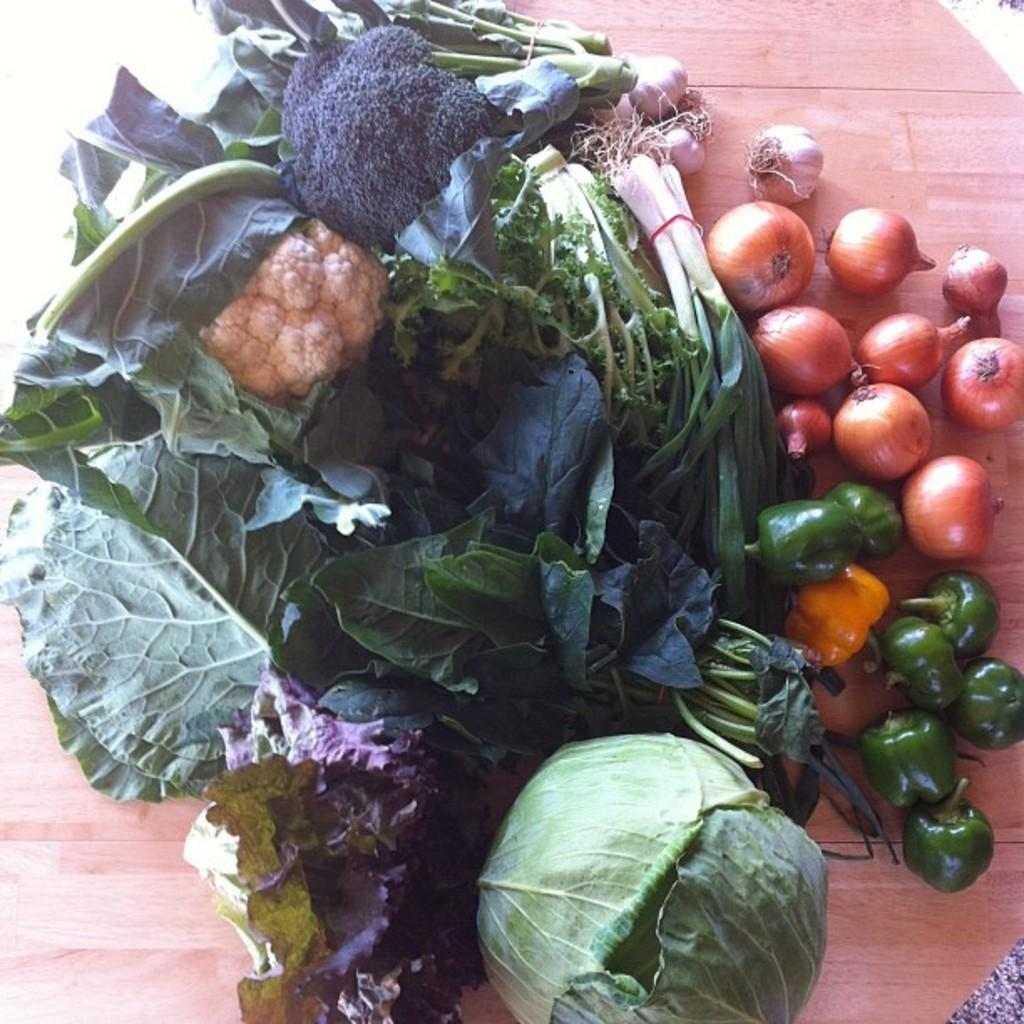What type of food items can be seen in the image? There are onions and other vegetables in the image. What material is the surface on which the vegetables are placed? The wooden surface is present in the image. What type of guitar is the governor playing in the image? There is no guitar or governor present in the image; it only features onions and other vegetables on a wooden surface. 